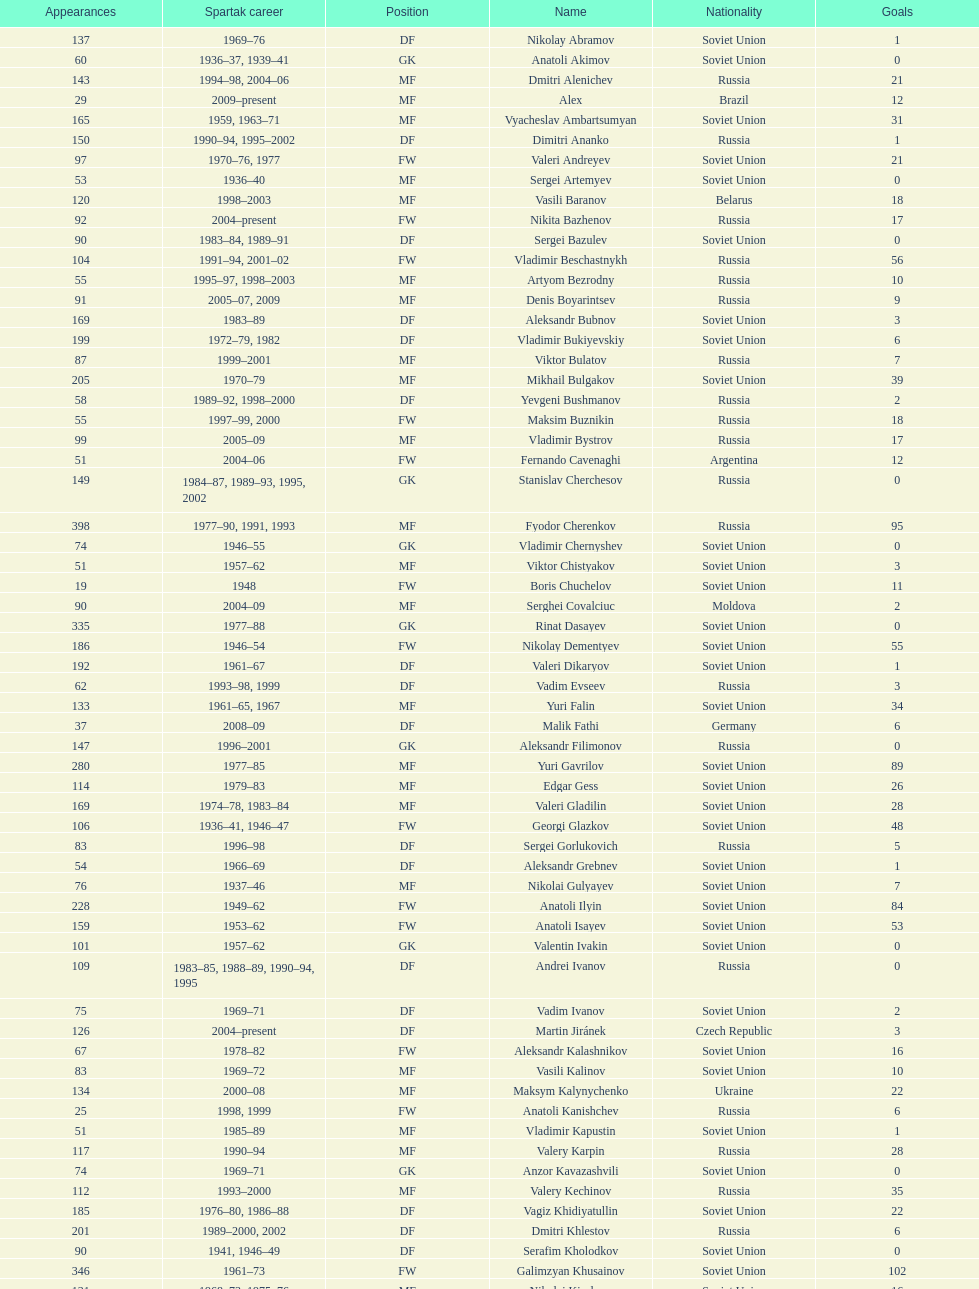Baranov has played from 2004 to the present. what is his nationality? Belarus. 